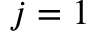<formula> <loc_0><loc_0><loc_500><loc_500>j = 1</formula> 